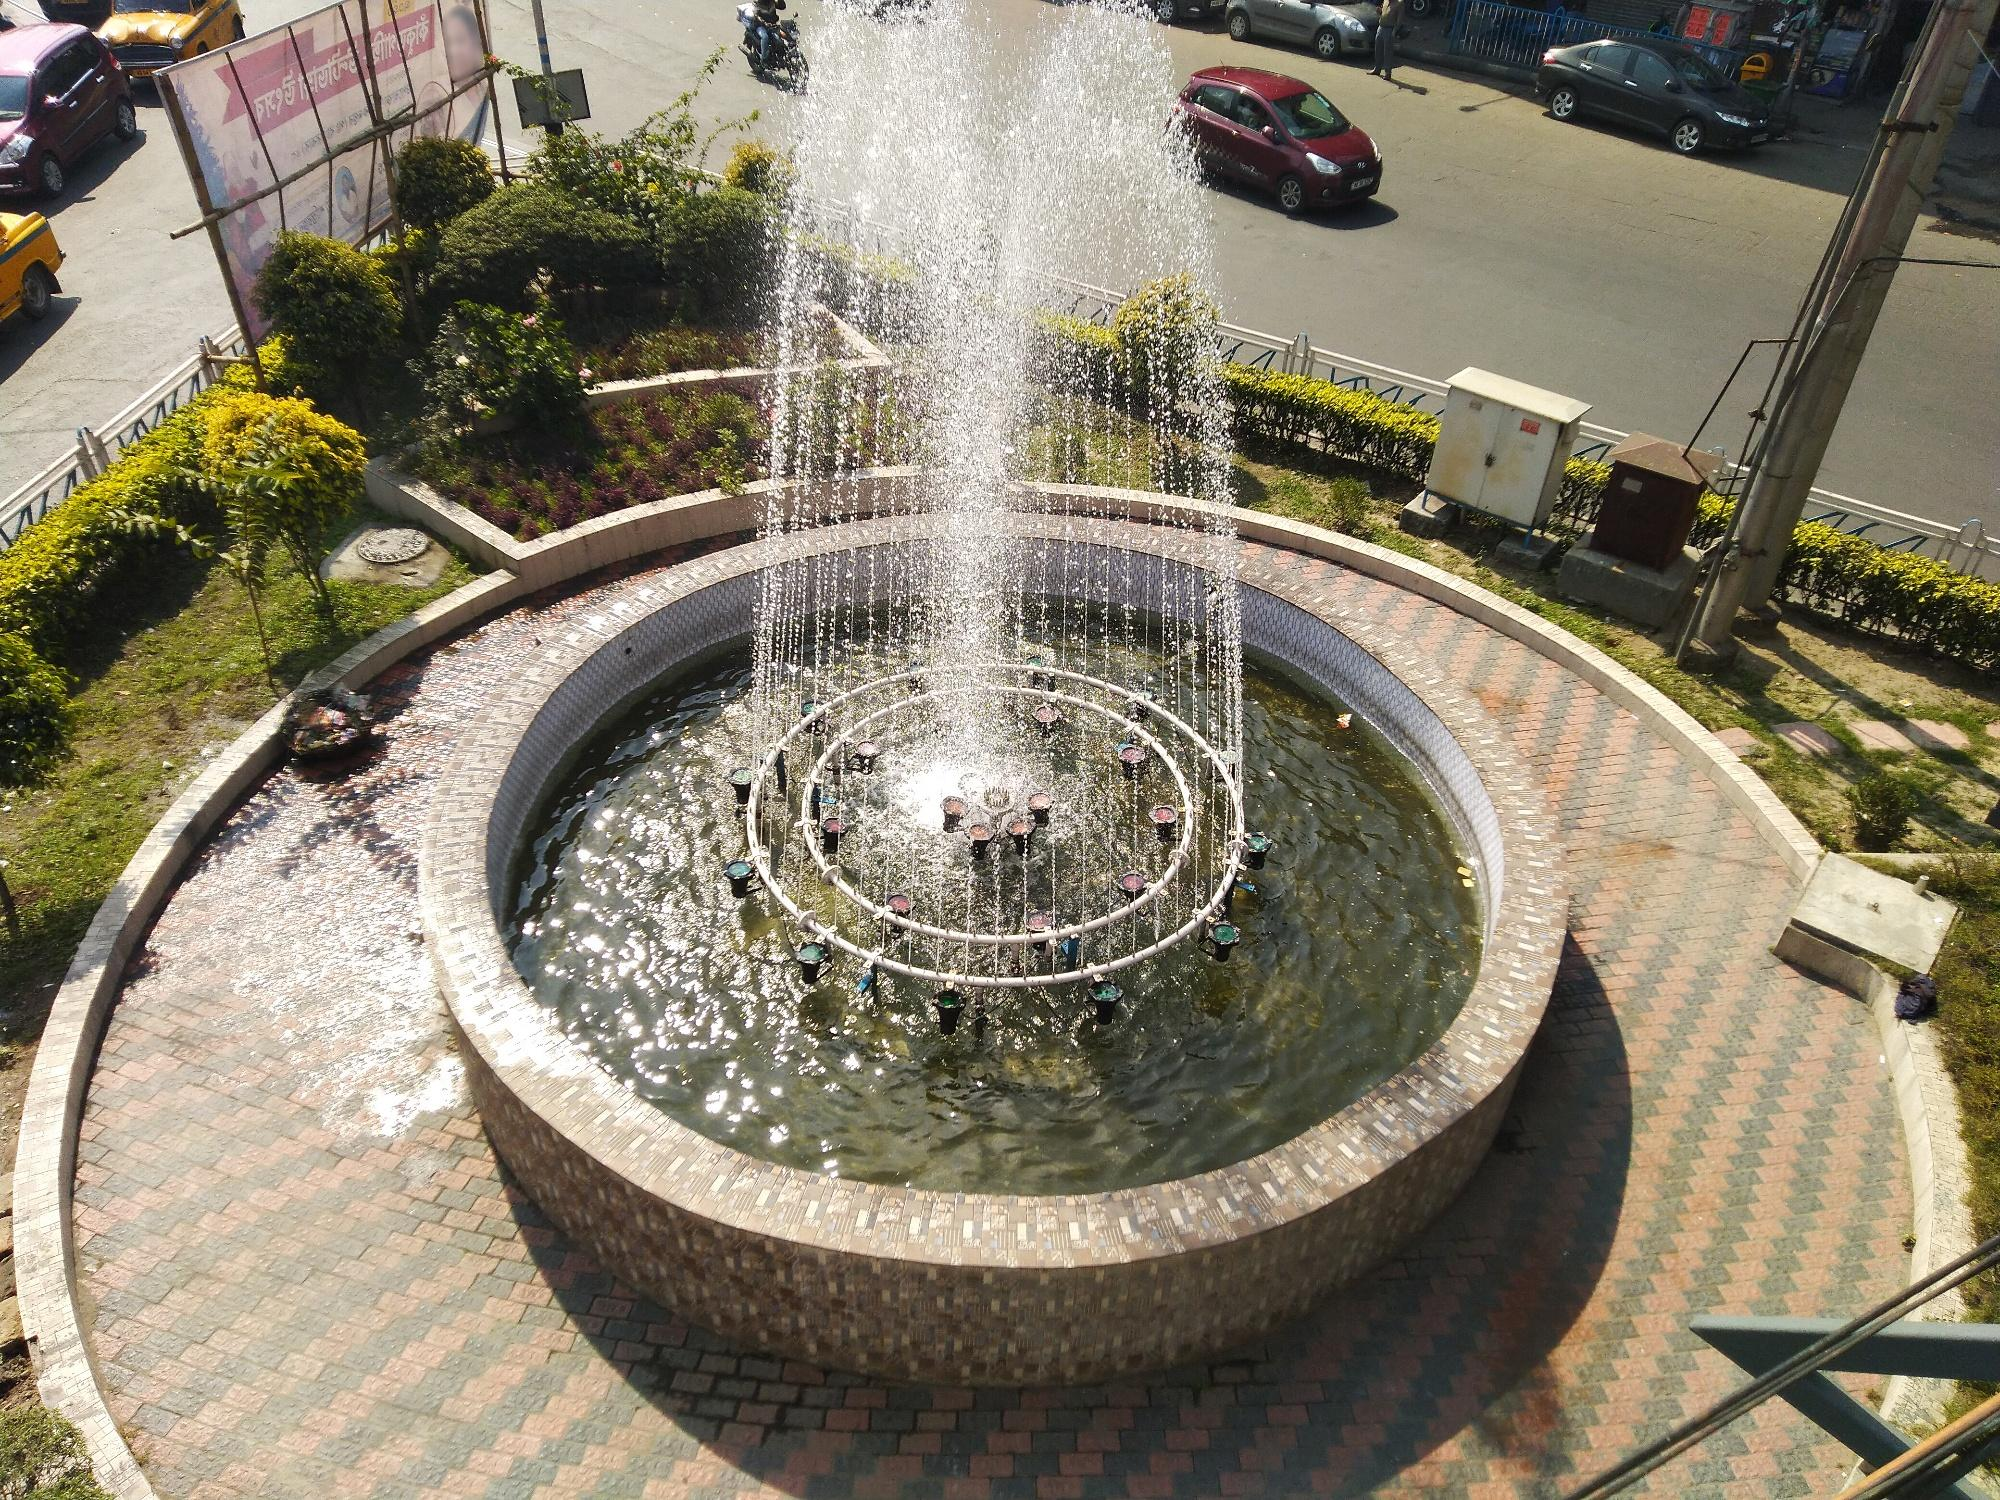Describe the following image. This image captures a beautifully designed fountain located in the center of a roundabout. The fountain's circular base is made of brick, and at its heart lies a smaller pool from which water shoots up dramatically. The water arcs gracefully, falling back into the pool and creating a mesmerizing visual display.

Surrounding the fountain is a well-maintained brick walkway that adds a touch of architectural charm. The greenery around the fountain, including bushes and precisely landscaped areas, contrasts wonderfully with the brick, adding vibrancy to the setting. This harmonious blend of natural and built elements makes the fountain a noteworthy urban feature.

In the backdrop, the dynamics of city life are evident with several cars negotiating the roundabout. Various buildings and structures, including a billboard and electrical boxes, are also noticeable, providing a sense of bustling activity and urban context. The image captures the essence of an urban oasis where nature and infrastructure meet, creating a space of relief and beauty within the city. 